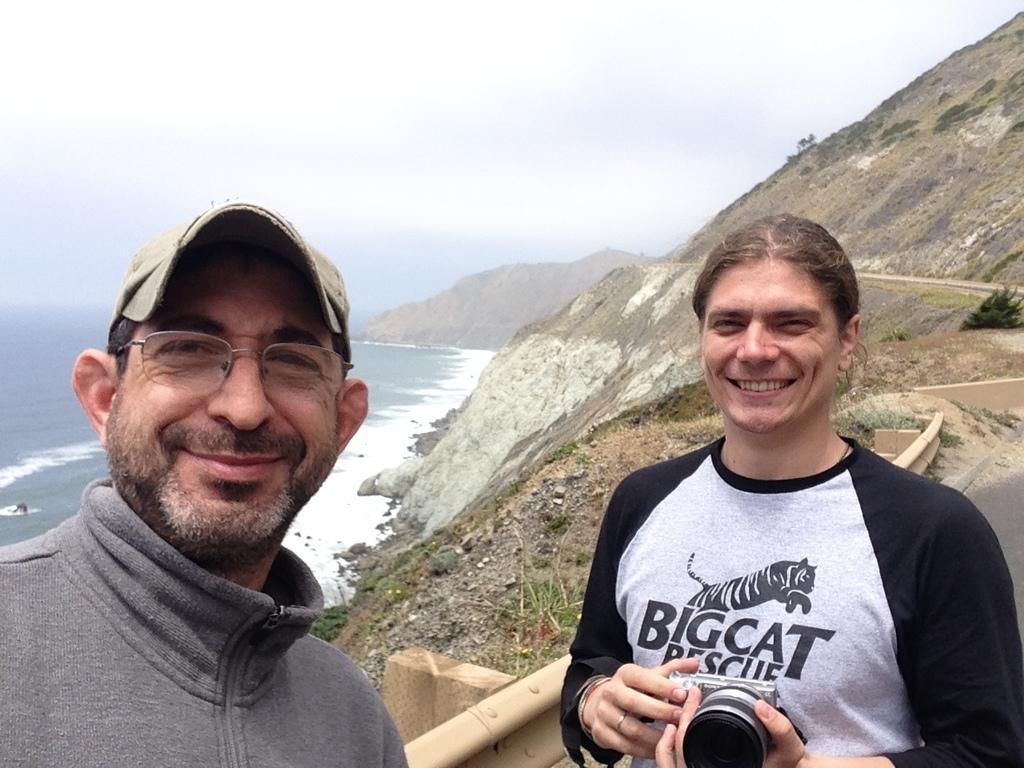In one or two sentences, can you explain what this image depicts? In this picture we can see man wore sweater, spectacle, cap and smiling beside to him other person holding camera in hands and smiling and in background we can see mountains, water, road, fence. 